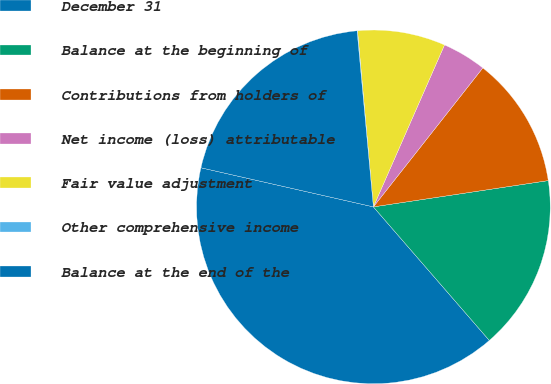Convert chart. <chart><loc_0><loc_0><loc_500><loc_500><pie_chart><fcel>December 31<fcel>Balance at the beginning of<fcel>Contributions from holders of<fcel>Net income (loss) attributable<fcel>Fair value adjustment<fcel>Other comprehensive income<fcel>Balance at the end of the<nl><fcel>39.93%<fcel>16.0%<fcel>12.01%<fcel>4.03%<fcel>8.02%<fcel>0.04%<fcel>19.98%<nl></chart> 